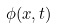Convert formula to latex. <formula><loc_0><loc_0><loc_500><loc_500>\phi ( x , t )</formula> 